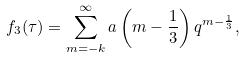Convert formula to latex. <formula><loc_0><loc_0><loc_500><loc_500>f _ { 3 } ( \tau ) = \sum _ { m = - k } ^ { \infty } a \left ( m - \frac { 1 } { 3 } \right ) q ^ { m - \frac { 1 } { 3 } } ,</formula> 